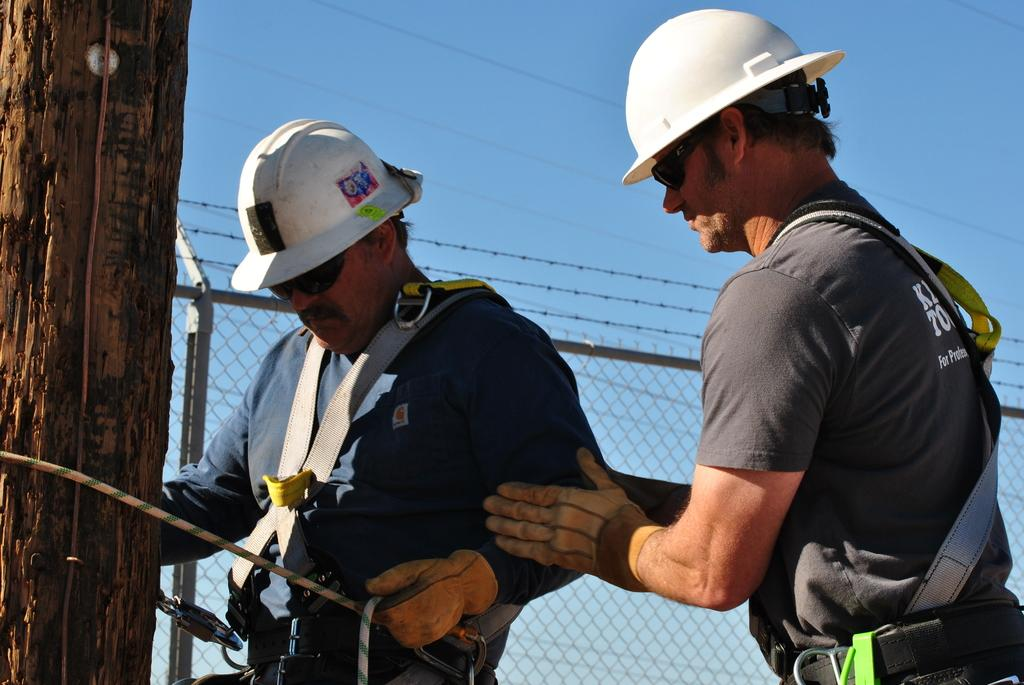What is the man in the image doing? The man in the image is working. What protective gear is the working man wearing? The working man is wearing a helmet. Can you describe the interaction between the two men in the image? The other man is holding the working man in the image. What can be seen in the background of the image? There is an iron net in the image. What is the color of the sky in the image? The sky is blue in color. What type of sticks are being used to maintain the plantation in the image? There is no plantation or sticks present in the image. 